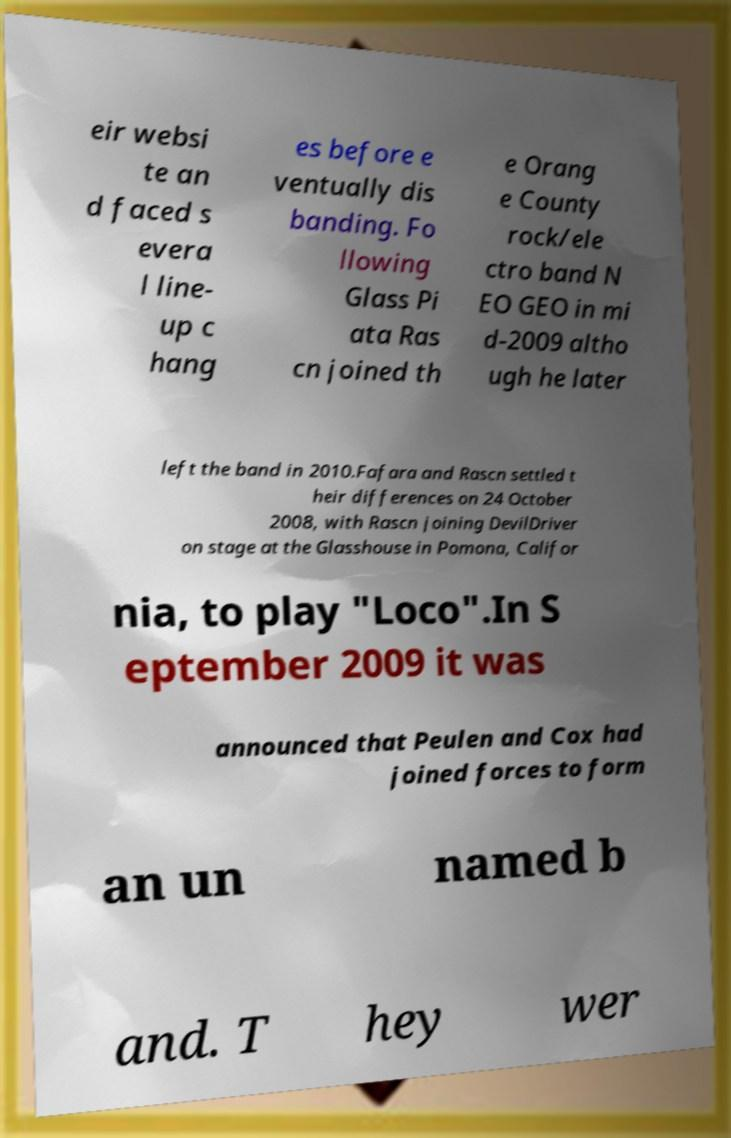I need the written content from this picture converted into text. Can you do that? eir websi te an d faced s evera l line- up c hang es before e ventually dis banding. Fo llowing Glass Pi ata Ras cn joined th e Orang e County rock/ele ctro band N EO GEO in mi d-2009 altho ugh he later left the band in 2010.Fafara and Rascn settled t heir differences on 24 October 2008, with Rascn joining DevilDriver on stage at the Glasshouse in Pomona, Califor nia, to play "Loco".In S eptember 2009 it was announced that Peulen and Cox had joined forces to form an un named b and. T hey wer 